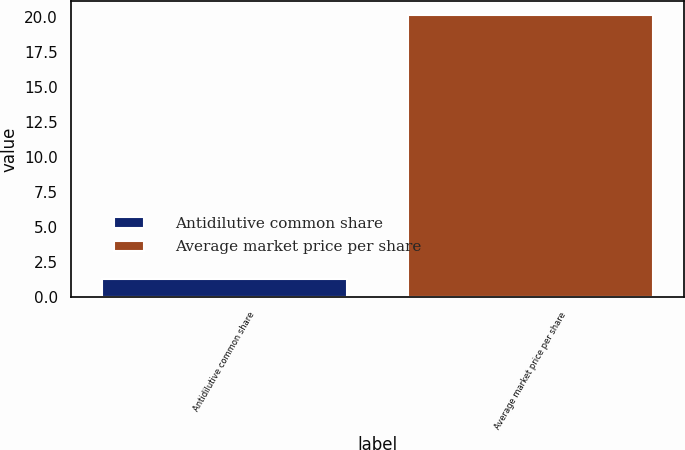Convert chart to OTSL. <chart><loc_0><loc_0><loc_500><loc_500><bar_chart><fcel>Antidilutive common share<fcel>Average market price per share<nl><fcel>1.3<fcel>20.17<nl></chart> 